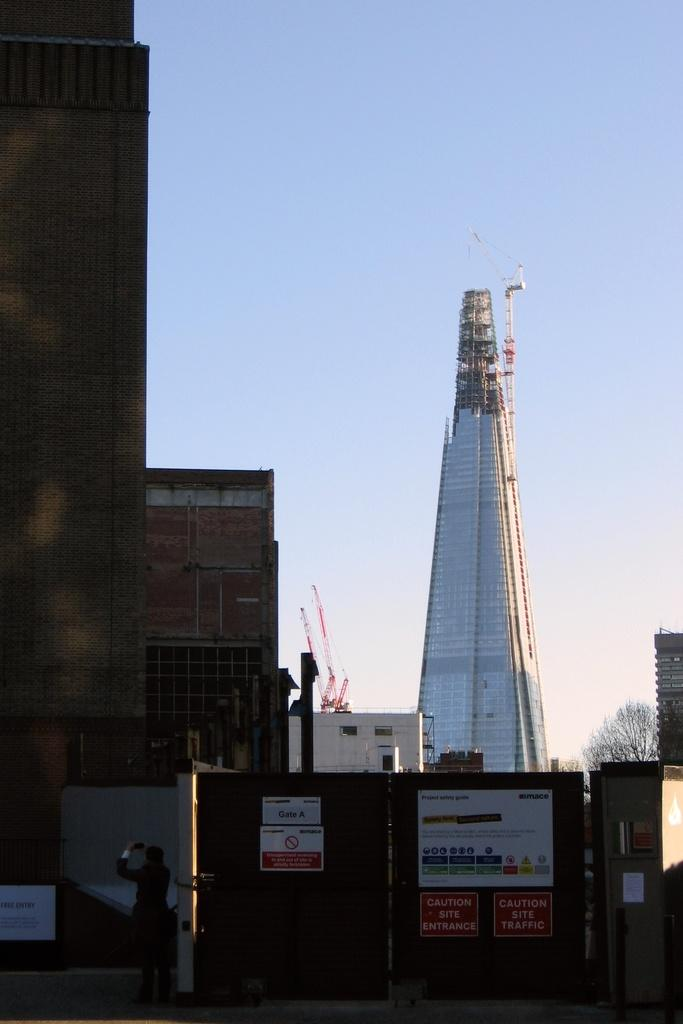What type of structures can be seen in the image? There are buildings in the image. What natural element is present in the image? There is a tree in the image. Can you describe the person in the image? There is a person standing in the image. What is visible in the background of the image? The sky is visible in the image. What agreement was reached between the sisters in the image? There are no sisters present in the image, and therefore no agreement can be discussed. What route is the person taking in the image? The image does not show the person taking any specific route; it only shows them standing. 